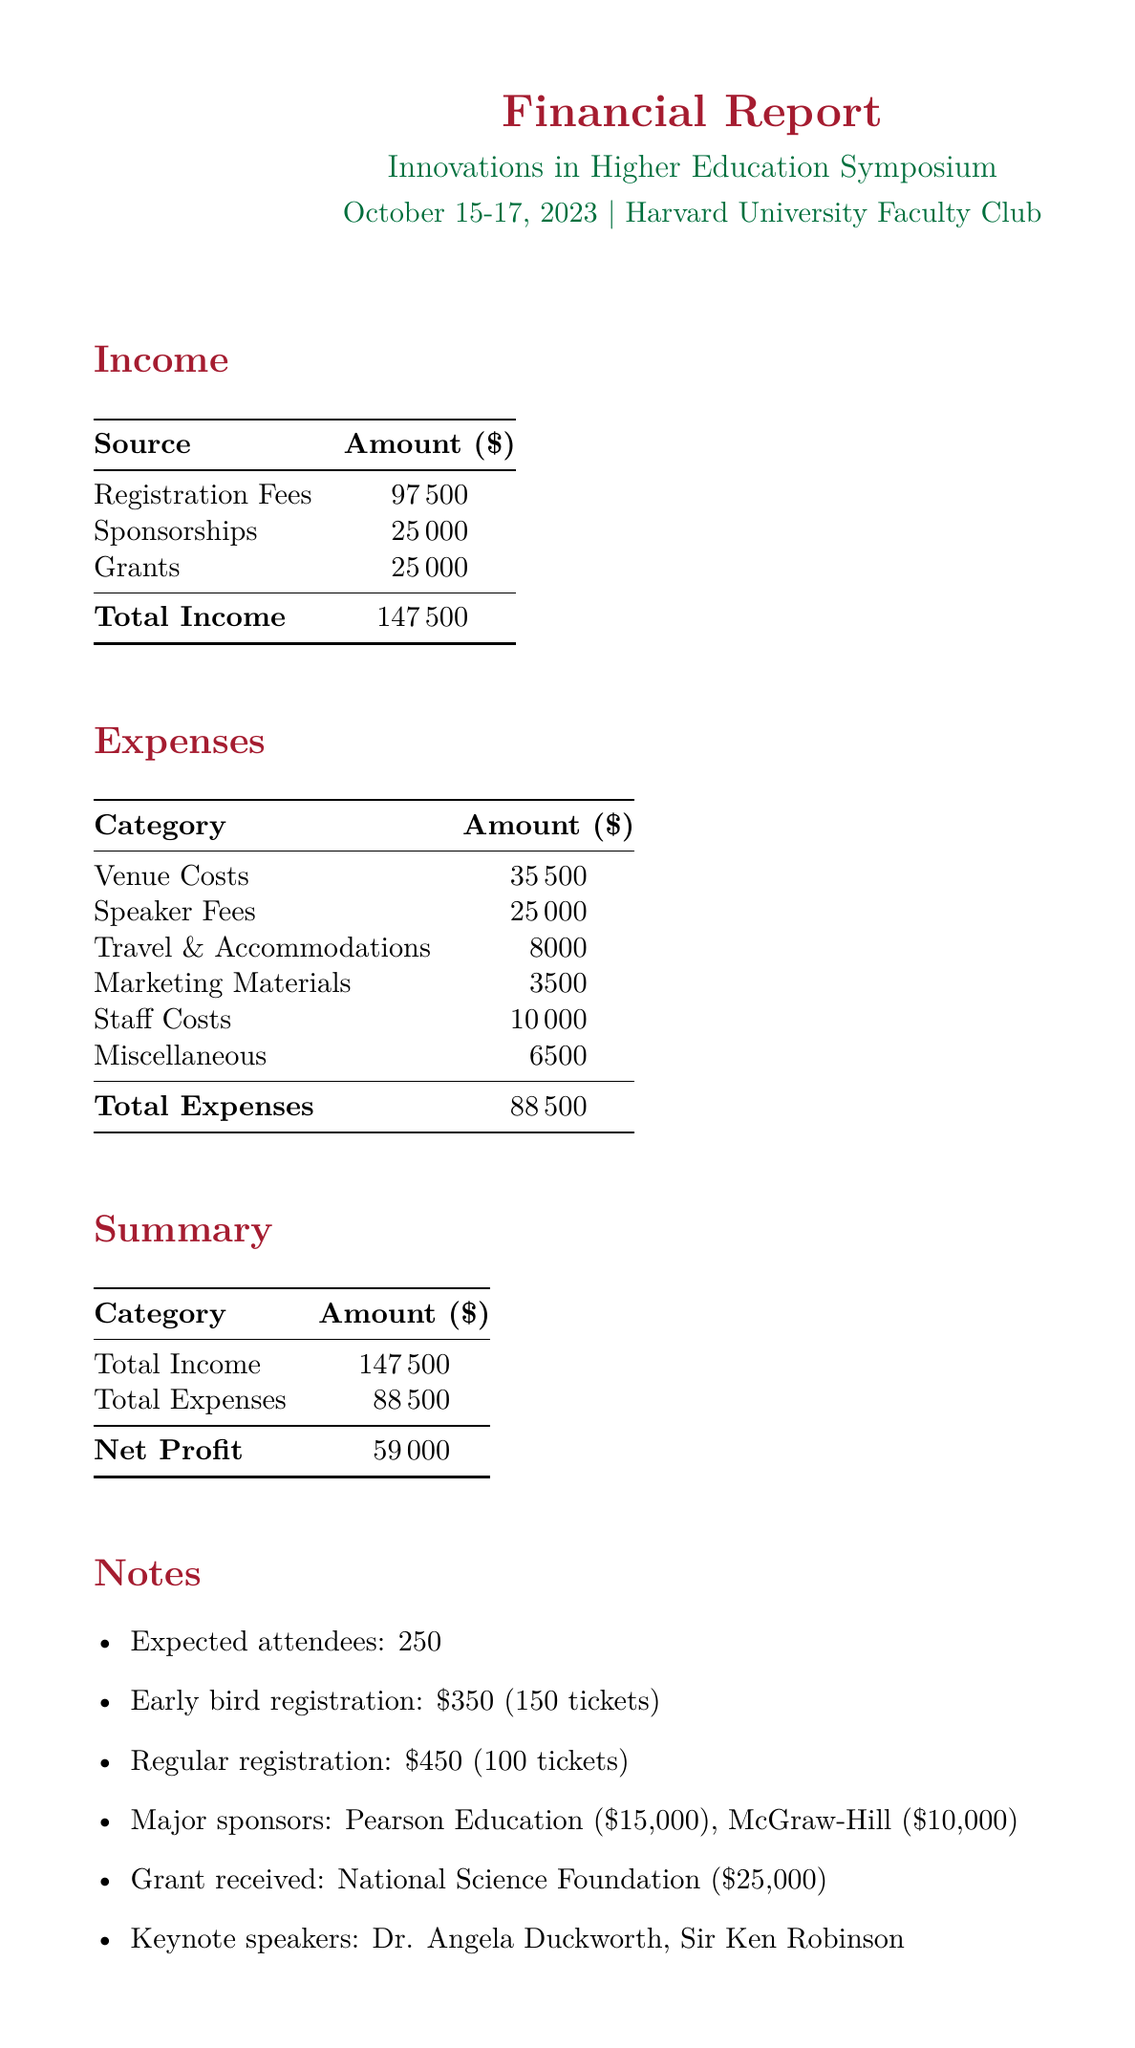What is the total income? The total income is listed in the document as the sum of registration fees, sponsorships, and grants, amounting to $147500.
Answer: $147500 What is the venue for the conference? The conference is hosted at the Harvard University Faculty Club, specifically mentioned in the document.
Answer: Harvard University Faculty Club What is the fee for Dr. Angela Duckworth? The document specifies Dr. Angela Duckworth's speaker fee, which is clearly listed as $10000.
Answer: $10000 How many early-bird registration tickets were sold? The document indicates that 150 early-bird tickets were sold as part of the registration fees.
Answer: 150 What is the total cost for venue expenses? The total venue costs are the sum of rental, catering, and audio-visual equipment costs, adding up to $35500 as shown in the expense section.
Answer: $35500 What is the net profit from the conference? The net profit is calculated as total income minus total expenses, which is $59000 according to the summary section of the document.
Answer: $59000 Who is the major grant provider mentioned? The document names the National Science Foundation as the source of a key grant received for the conference.
Answer: National Science Foundation What are the travel accommodations for organizers? The travel accommodations for organizers amount to $3000, as specified in the expenses section.
Answer: $3000 How much did Pearson Education contribute as a sponsor? The document lists Pearson Education's sponsorship amount as $15000, which is part of the overall sponsorships listed.
Answer: $15000 